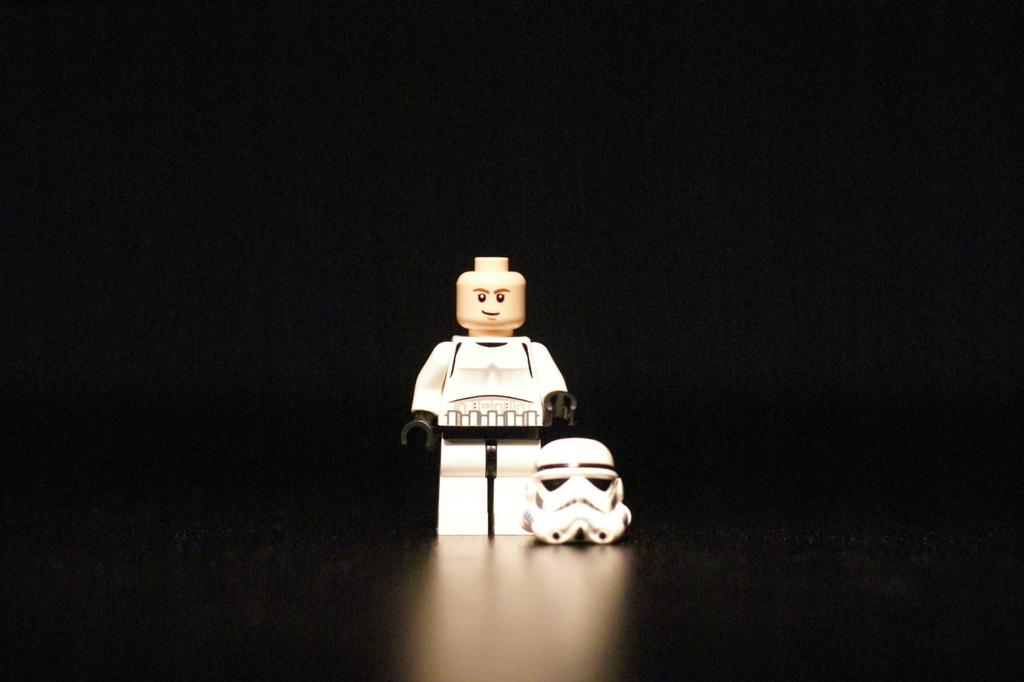What type of toy is in the image? There is a Lego toy in the image. What color is the helmet that is part of the toy? The helmet is white. What color is the background of the image? The background of the image is black. What type of clover can be seen growing in the background of the image? There is no clover present in the image; the background is black. What time of day is depicted in the image? The time of day is not indicated in the image. 